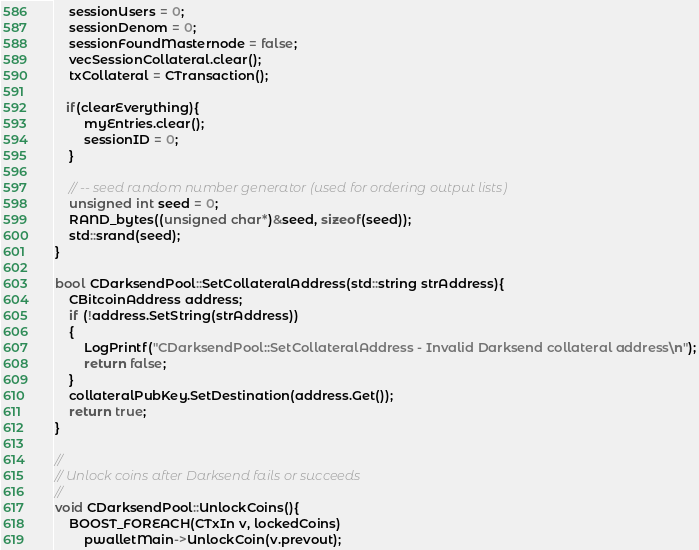Convert code to text. <code><loc_0><loc_0><loc_500><loc_500><_C++_>    sessionUsers = 0;
    sessionDenom = 0;
    sessionFoundMasternode = false;
    vecSessionCollateral.clear();
    txCollateral = CTransaction();

   if(clearEverything){
        myEntries.clear();
        sessionID = 0;
    }

    // -- seed random number generator (used for ordering output lists)
    unsigned int seed = 0;
    RAND_bytes((unsigned char*)&seed, sizeof(seed));
    std::srand(seed);
}

bool CDarksendPool::SetCollateralAddress(std::string strAddress){
    CBitcoinAddress address;
    if (!address.SetString(strAddress))
    {
        LogPrintf("CDarksendPool::SetCollateralAddress - Invalid Darksend collateral address\n");
        return false;
    }
    collateralPubKey.SetDestination(address.Get());
    return true;
}

//
// Unlock coins after Darksend fails or succeeds
//
void CDarksendPool::UnlockCoins(){
    BOOST_FOREACH(CTxIn v, lockedCoins)
        pwalletMain->UnlockCoin(v.prevout);
</code> 